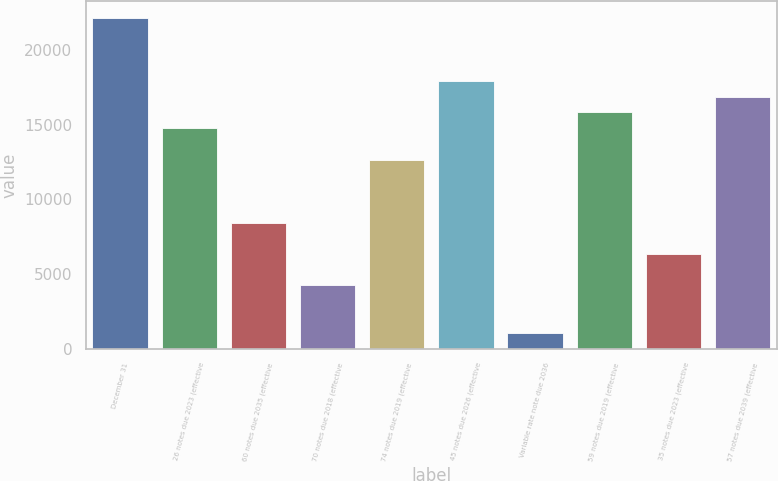Convert chart to OTSL. <chart><loc_0><loc_0><loc_500><loc_500><bar_chart><fcel>December 31<fcel>26 notes due 2023 (effective<fcel>60 notes due 2035 (effective<fcel>70 notes due 2018 (effective<fcel>74 notes due 2019 (effective<fcel>45 notes due 2026 (effective<fcel>Variable rate note due 2036<fcel>59 notes due 2019 (effective<fcel>35 notes due 2023 (effective<fcel>57 notes due 2039 (effective<nl><fcel>22165<fcel>14780<fcel>8450<fcel>4230<fcel>12670<fcel>17945<fcel>1065<fcel>15835<fcel>6340<fcel>16890<nl></chart> 